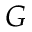Convert formula to latex. <formula><loc_0><loc_0><loc_500><loc_500>G</formula> 